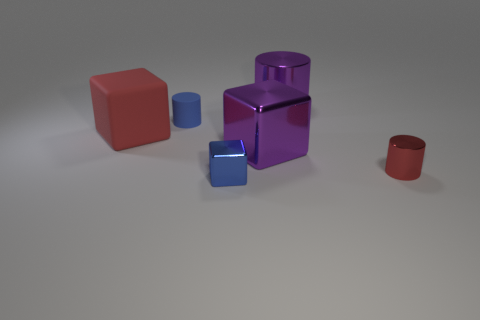There is a rubber cylinder; does it have the same color as the small shiny thing that is left of the purple shiny cylinder?
Make the answer very short. Yes. There is a shiny cylinder behind the big cube behind the large purple shiny block; what number of tiny cylinders are to the right of it?
Offer a very short reply. 1. Are there any small objects in front of the purple shiny cube?
Your response must be concise. Yes. Are there any other things that have the same color as the tiny cube?
Your answer should be compact. Yes. What number of balls are either red objects or blue matte objects?
Your answer should be very brief. 0. What number of things are both behind the small red metal thing and in front of the red matte object?
Offer a terse response. 1. Are there an equal number of tiny matte objects behind the large purple cylinder and small red cylinders in front of the big purple block?
Your answer should be compact. No. There is a small metal thing to the right of the big purple cylinder; does it have the same shape as the big red object?
Keep it short and to the point. No. There is a metallic object behind the large purple block that is on the left side of the red object to the right of the large red block; what shape is it?
Ensure brevity in your answer.  Cylinder. There is a shiny thing that is the same color as the big metallic cube; what is its shape?
Your response must be concise. Cylinder. 